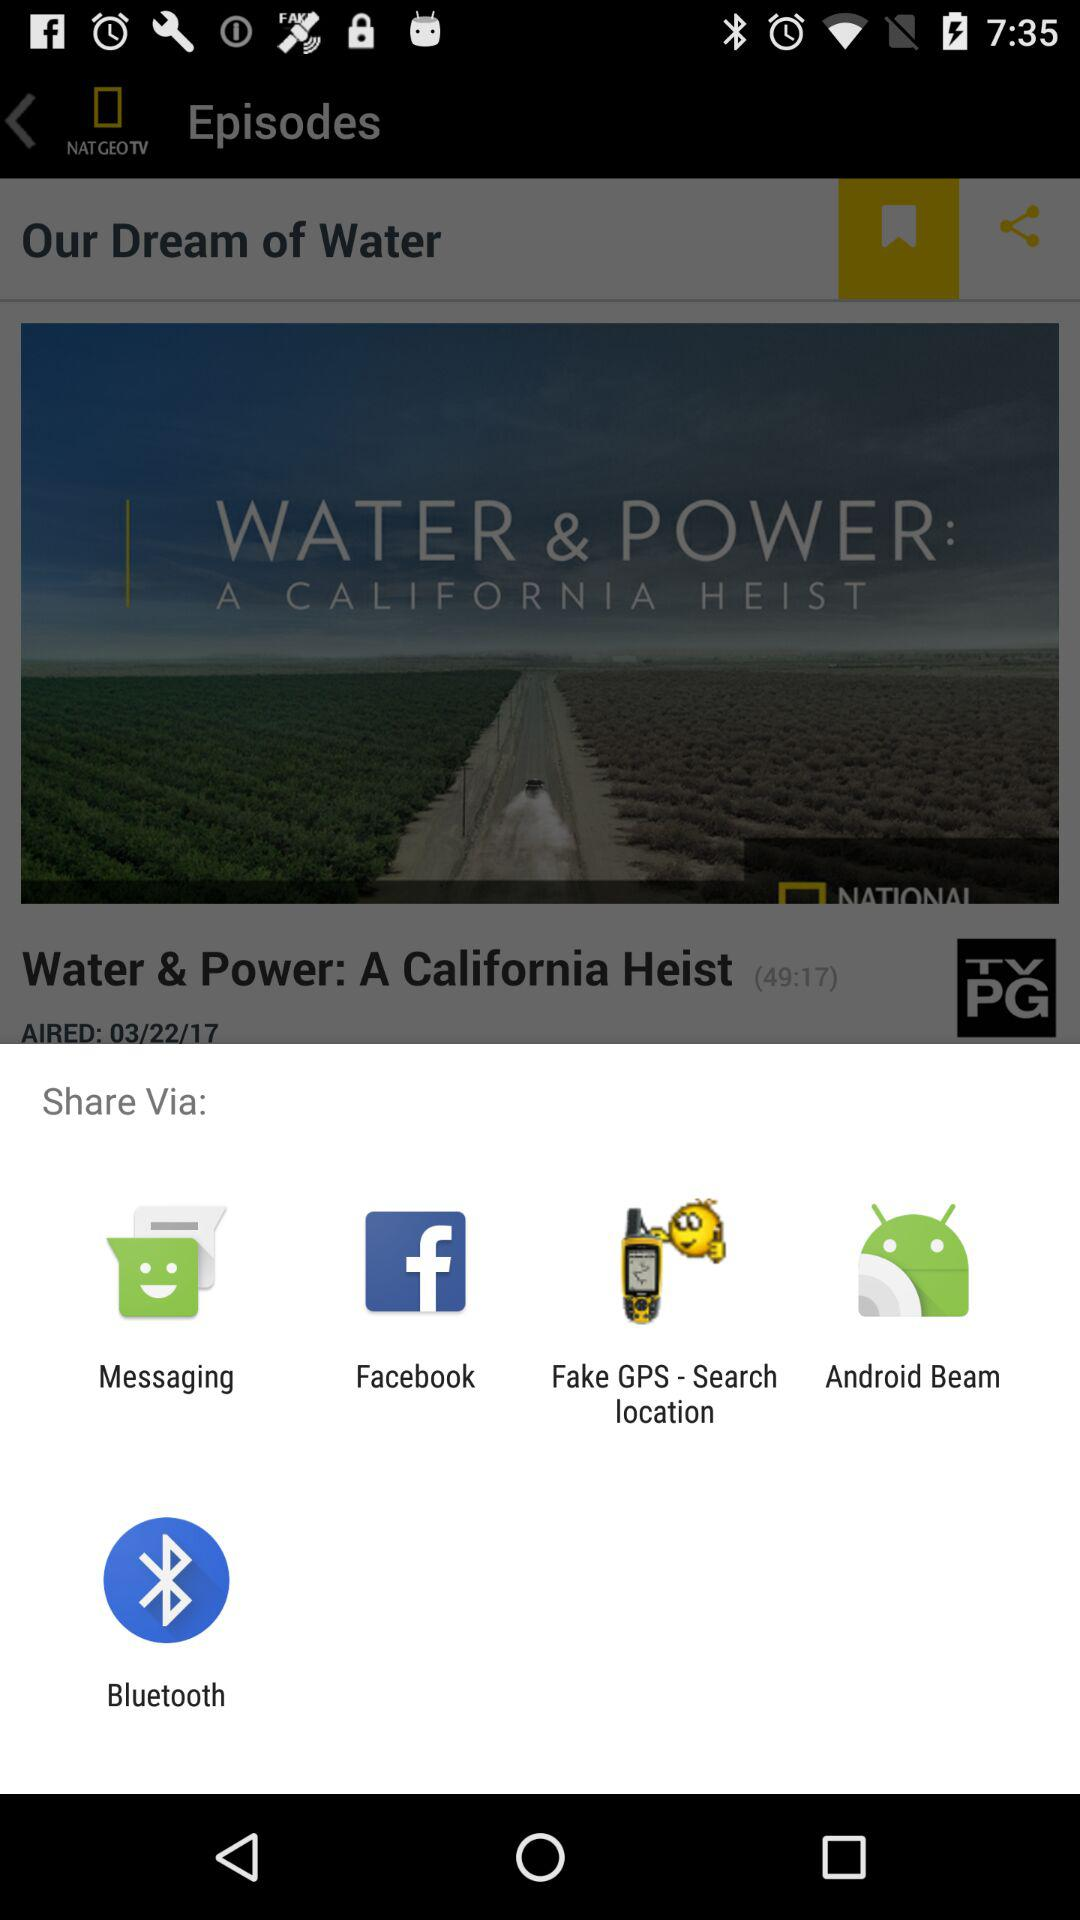Through what options can we share it? You can share it through "Messaging", "Facebook", "Fake GPS - Search location", "Android Beam" and "Bluetooth". 